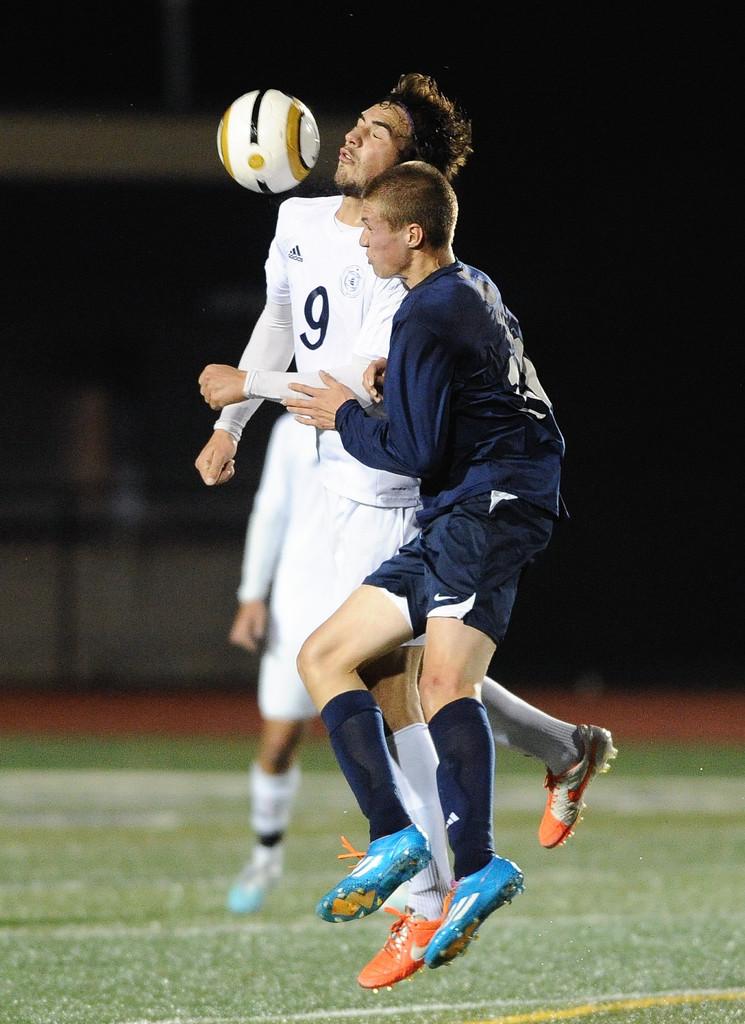What number is the white shirted player?
Your response must be concise. 9. What brand is the white jersey?
Make the answer very short. Adidas. 